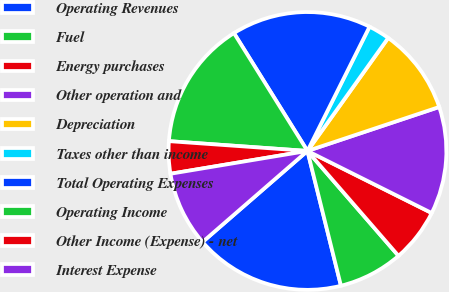Convert chart to OTSL. <chart><loc_0><loc_0><loc_500><loc_500><pie_chart><fcel>Operating Revenues<fcel>Fuel<fcel>Energy purchases<fcel>Other operation and<fcel>Depreciation<fcel>Taxes other than income<fcel>Total Operating Expenses<fcel>Operating Income<fcel>Other Income (Expense) - net<fcel>Interest Expense<nl><fcel>17.5%<fcel>7.5%<fcel>6.25%<fcel>12.5%<fcel>10.0%<fcel>2.5%<fcel>16.25%<fcel>15.0%<fcel>3.75%<fcel>8.75%<nl></chart> 